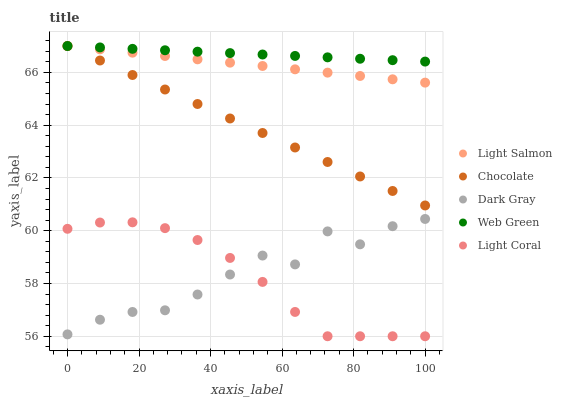Does Light Coral have the minimum area under the curve?
Answer yes or no. Yes. Does Web Green have the maximum area under the curve?
Answer yes or no. Yes. Does Light Salmon have the minimum area under the curve?
Answer yes or no. No. Does Light Salmon have the maximum area under the curve?
Answer yes or no. No. Is Chocolate the smoothest?
Answer yes or no. Yes. Is Dark Gray the roughest?
Answer yes or no. Yes. Is Light Coral the smoothest?
Answer yes or no. No. Is Light Coral the roughest?
Answer yes or no. No. Does Light Coral have the lowest value?
Answer yes or no. Yes. Does Light Salmon have the lowest value?
Answer yes or no. No. Does Chocolate have the highest value?
Answer yes or no. Yes. Does Light Coral have the highest value?
Answer yes or no. No. Is Light Coral less than Web Green?
Answer yes or no. Yes. Is Light Salmon greater than Light Coral?
Answer yes or no. Yes. Does Dark Gray intersect Light Coral?
Answer yes or no. Yes. Is Dark Gray less than Light Coral?
Answer yes or no. No. Is Dark Gray greater than Light Coral?
Answer yes or no. No. Does Light Coral intersect Web Green?
Answer yes or no. No. 